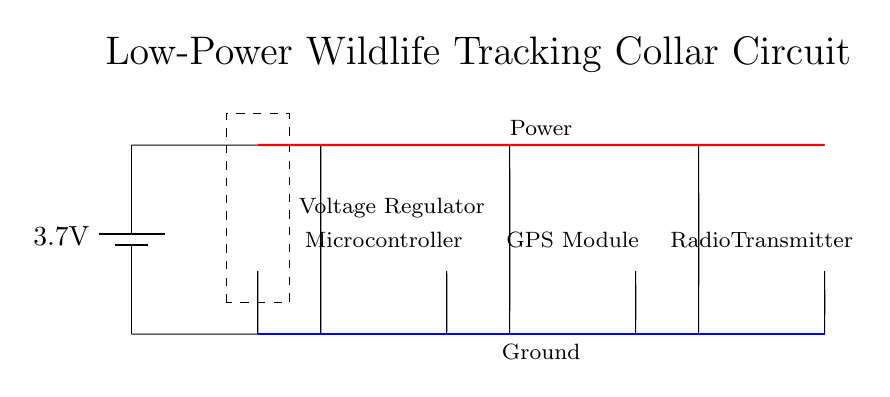What is the voltage of the battery? The circuit shows a battery marked with a voltage of 3.7 volts. This is the potential difference provided by the battery to power the circuit.
Answer: 3.7 volts What components are included in this circuit diagram? The circuit diagram includes a battery, a voltage regulator, a microcontroller, a GPS module, and a radio transmitter. Each component is represented separately, and their functions can be inferred from their standard symbols.
Answer: Battery, Voltage Regulator, Microcontroller, GPS Module, Radio Transmitter How many main components are powered by the voltage regulator? The voltage regulator powers three components: the microcontroller, the GPS module, and the radio transmitter. Each of these components is connected to the output of the voltage regulator, as indicated by the connections drawn in the circuit.
Answer: Three components What kind of circuit is this diagram representing? The circuit diagram represents a low-power wildlife tracking collar circuit, which utilizes a battery-powered system incorporating a GPS module and a radio transmitter for tracking purposes. This application requires low power consumption to ensure prolonged operation in the field.
Answer: Low-power wildlife tracking collar circuit What is the function of the voltage regulator in the circuit? The voltage regulator takes the input voltage from the battery and maintains a consistent output voltage suitable for the microcontroller and other components, ensuring they operate within their required voltage specifications.
Answer: To maintain consistent output voltage 